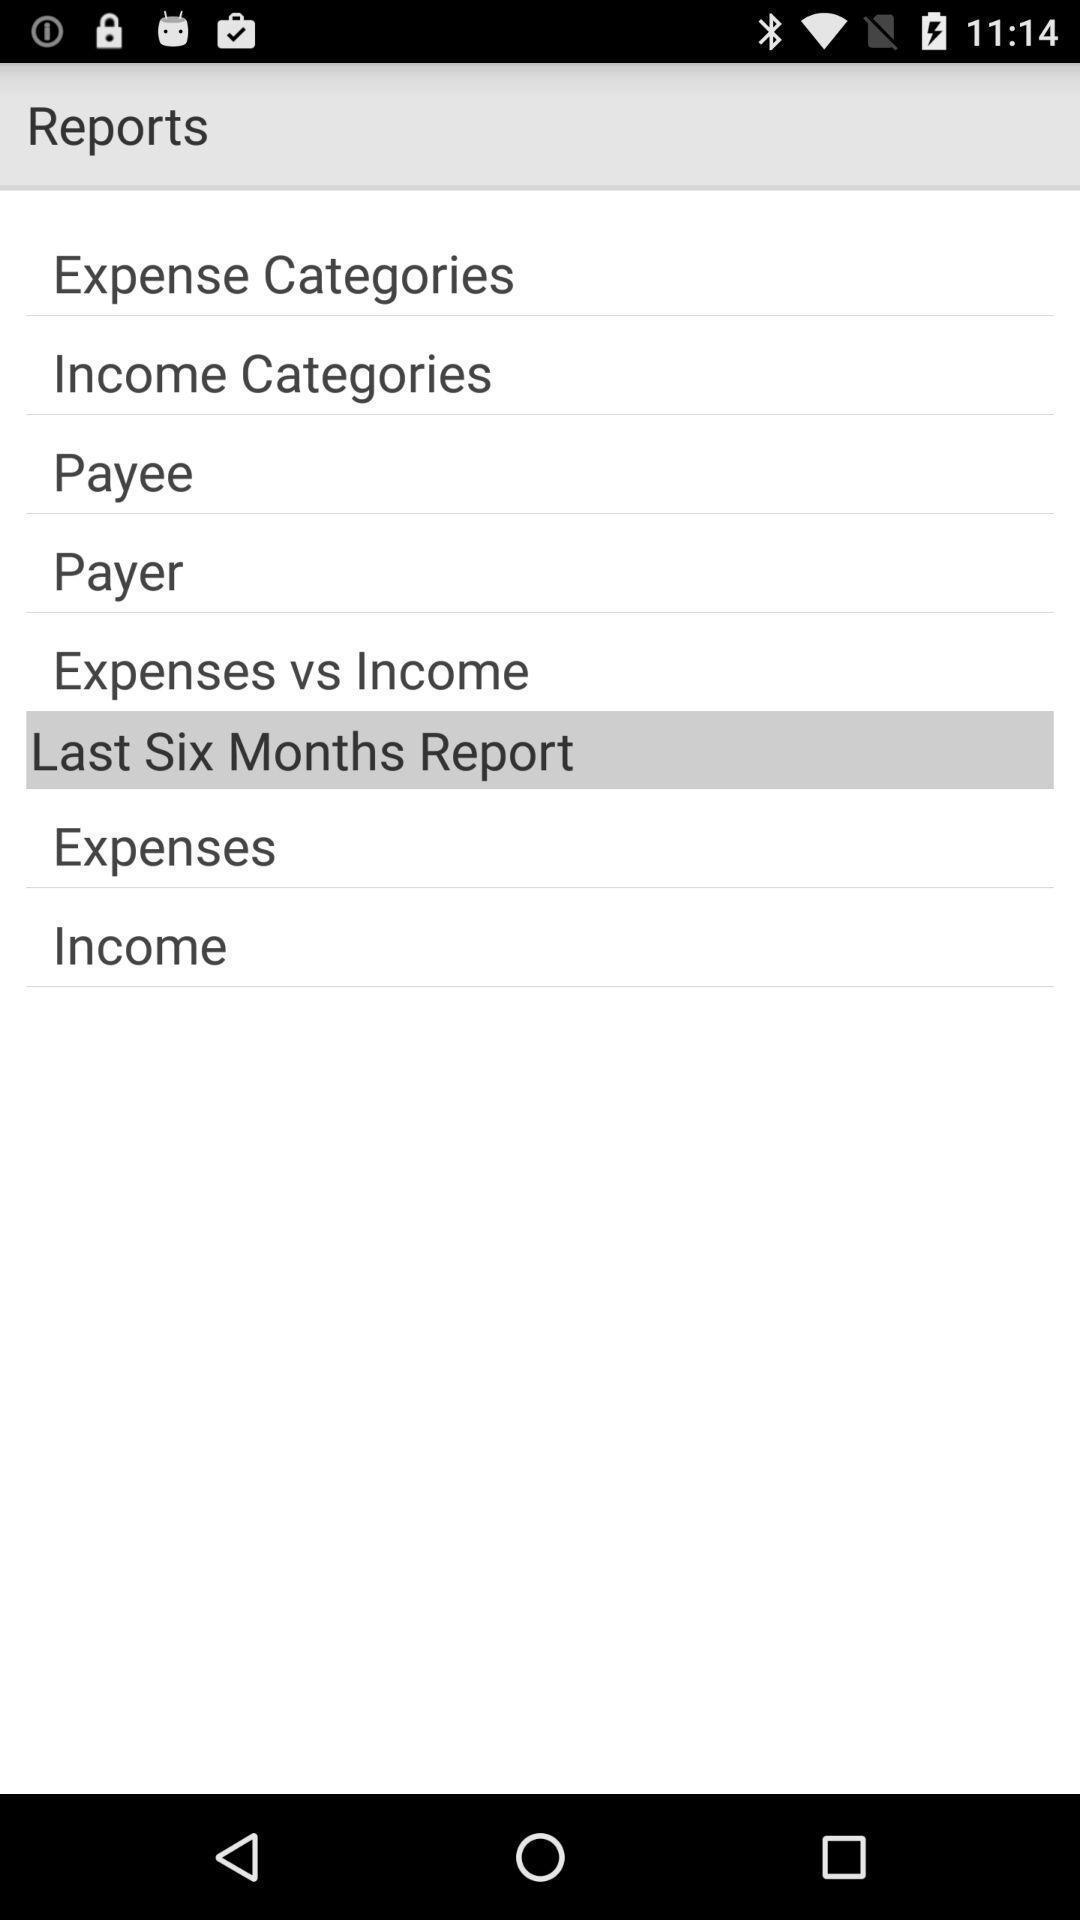Summarize the main components in this picture. Page showing different options for reports. 